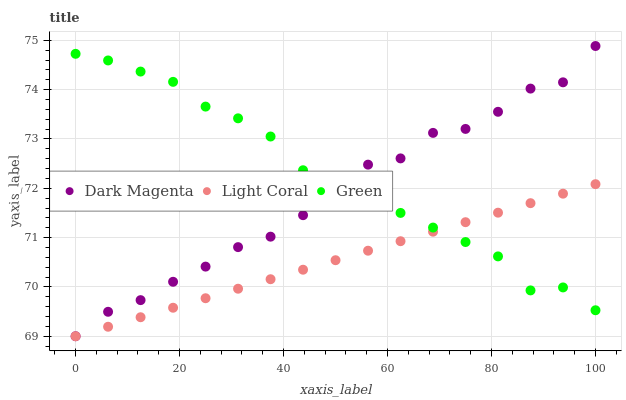Does Light Coral have the minimum area under the curve?
Answer yes or no. Yes. Does Green have the maximum area under the curve?
Answer yes or no. Yes. Does Dark Magenta have the minimum area under the curve?
Answer yes or no. No. Does Dark Magenta have the maximum area under the curve?
Answer yes or no. No. Is Light Coral the smoothest?
Answer yes or no. Yes. Is Dark Magenta the roughest?
Answer yes or no. Yes. Is Green the smoothest?
Answer yes or no. No. Is Green the roughest?
Answer yes or no. No. Does Light Coral have the lowest value?
Answer yes or no. Yes. Does Green have the lowest value?
Answer yes or no. No. Does Dark Magenta have the highest value?
Answer yes or no. Yes. Does Green have the highest value?
Answer yes or no. No. Does Dark Magenta intersect Light Coral?
Answer yes or no. Yes. Is Dark Magenta less than Light Coral?
Answer yes or no. No. Is Dark Magenta greater than Light Coral?
Answer yes or no. No. 